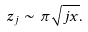Convert formula to latex. <formula><loc_0><loc_0><loc_500><loc_500>z _ { j } \sim \pi \sqrt { j x } .</formula> 